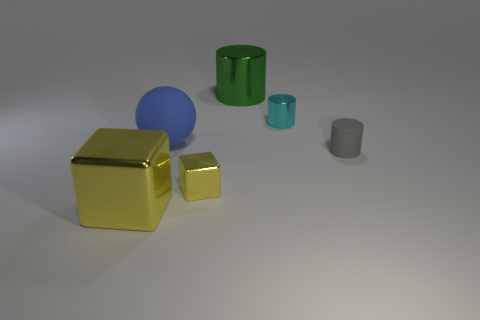Add 2 tiny metal cylinders. How many objects exist? 8 Subtract all metallic cylinders. How many cylinders are left? 1 Subtract 1 cubes. How many cubes are left? 1 Subtract all big yellow blocks. Subtract all gray objects. How many objects are left? 4 Add 1 big spheres. How many big spheres are left? 2 Add 2 tiny rubber things. How many tiny rubber things exist? 3 Subtract all gray cylinders. How many cylinders are left? 2 Subtract 0 brown blocks. How many objects are left? 6 Subtract all spheres. How many objects are left? 5 Subtract all blue cylinders. Subtract all yellow spheres. How many cylinders are left? 3 